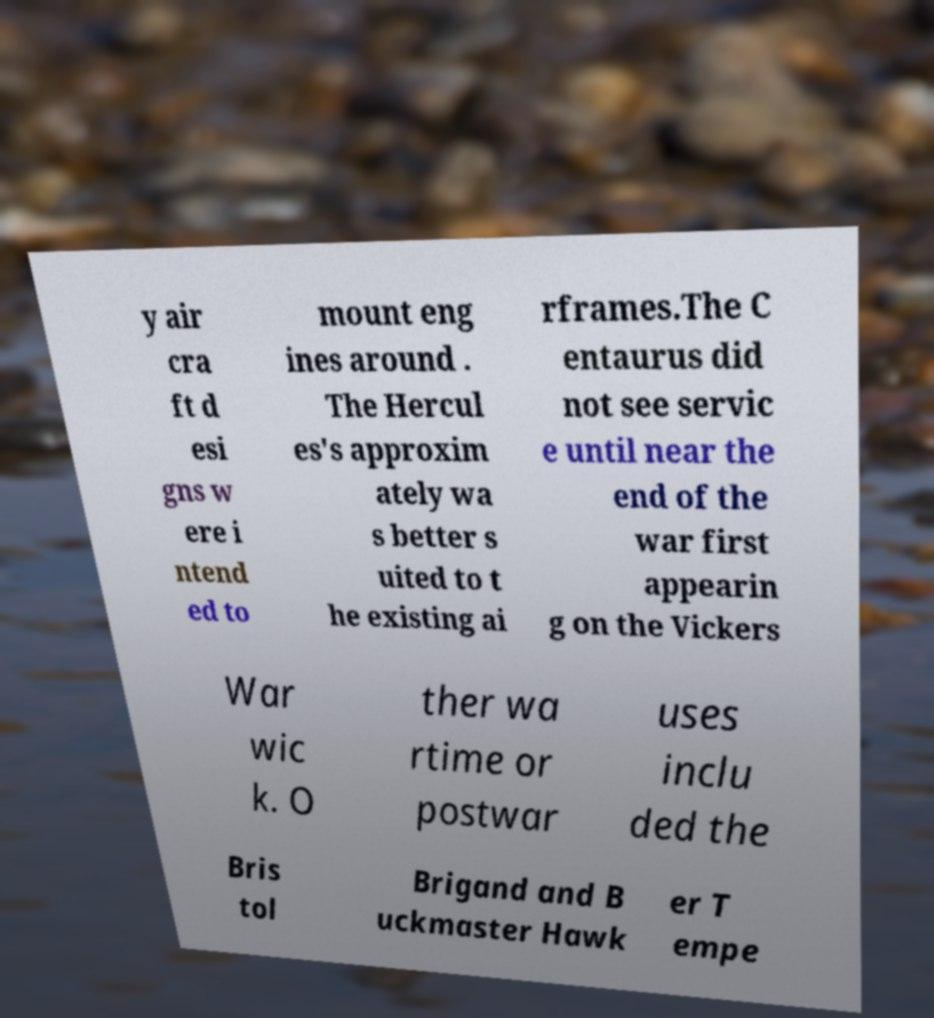What messages or text are displayed in this image? I need them in a readable, typed format. y air cra ft d esi gns w ere i ntend ed to mount eng ines around . The Hercul es's approxim ately wa s better s uited to t he existing ai rframes.The C entaurus did not see servic e until near the end of the war first appearin g on the Vickers War wic k. O ther wa rtime or postwar uses inclu ded the Bris tol Brigand and B uckmaster Hawk er T empe 